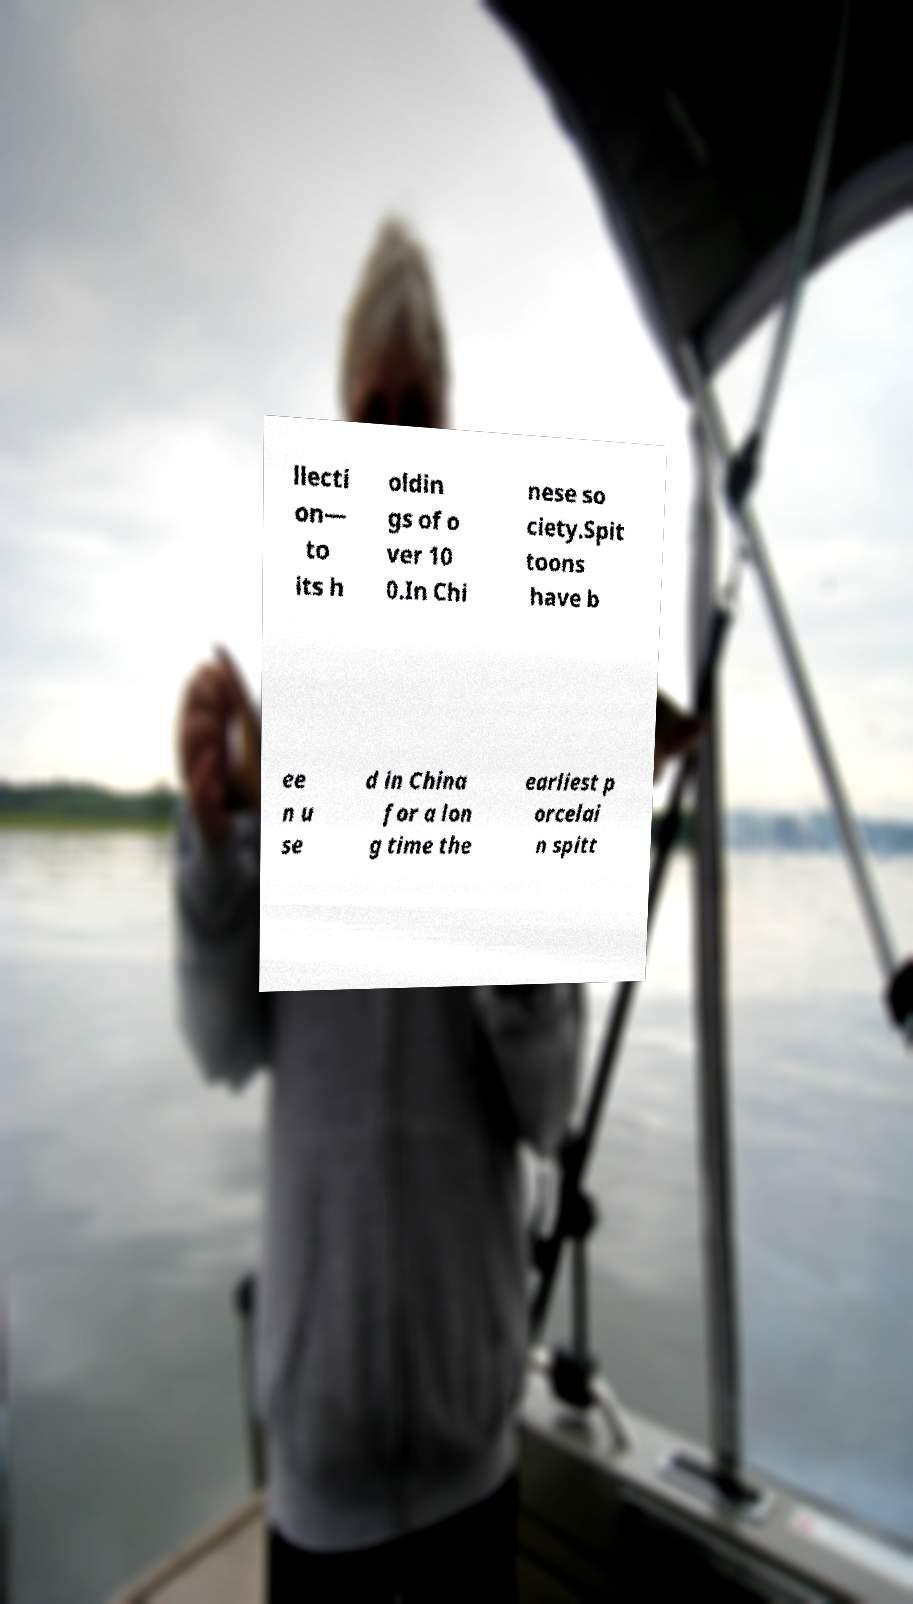There's text embedded in this image that I need extracted. Can you transcribe it verbatim? llecti on— to its h oldin gs of o ver 10 0.In Chi nese so ciety.Spit toons have b ee n u se d in China for a lon g time the earliest p orcelai n spitt 